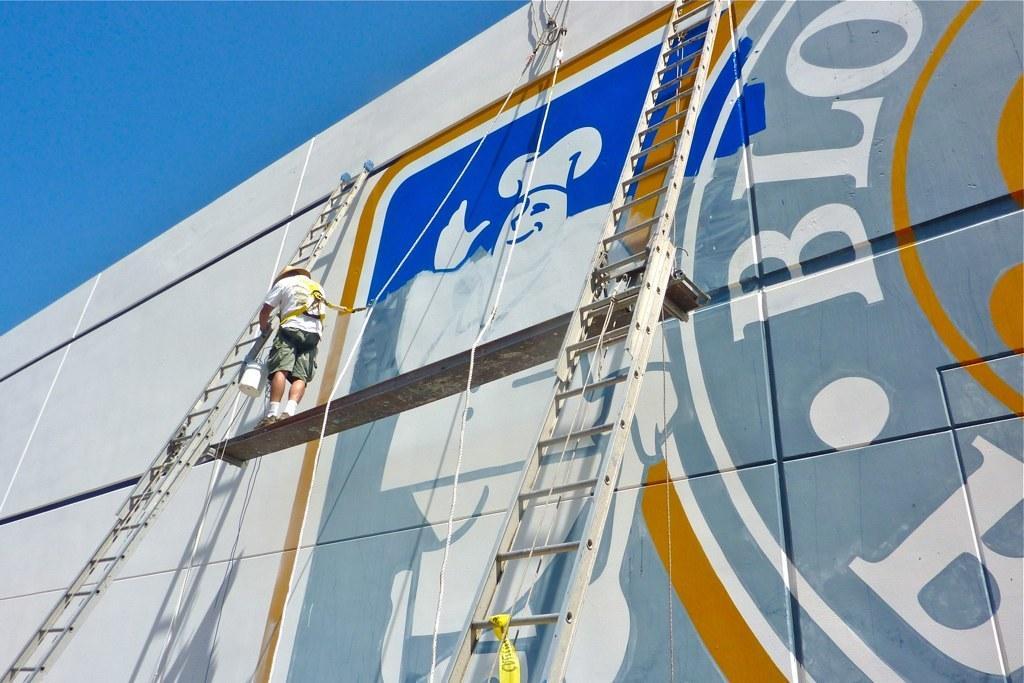How would you summarize this image in a sentence or two? In this image we can see a metal rod is hang to the wall with the help of ropes and one man is standing on it. He is wearing white t-shirt and shorts. The man is holding bucket in his hand. And we can see two ladders. Background of the image we can see big wall with some painting and text. In the left top corner of the image we can see the sky. 